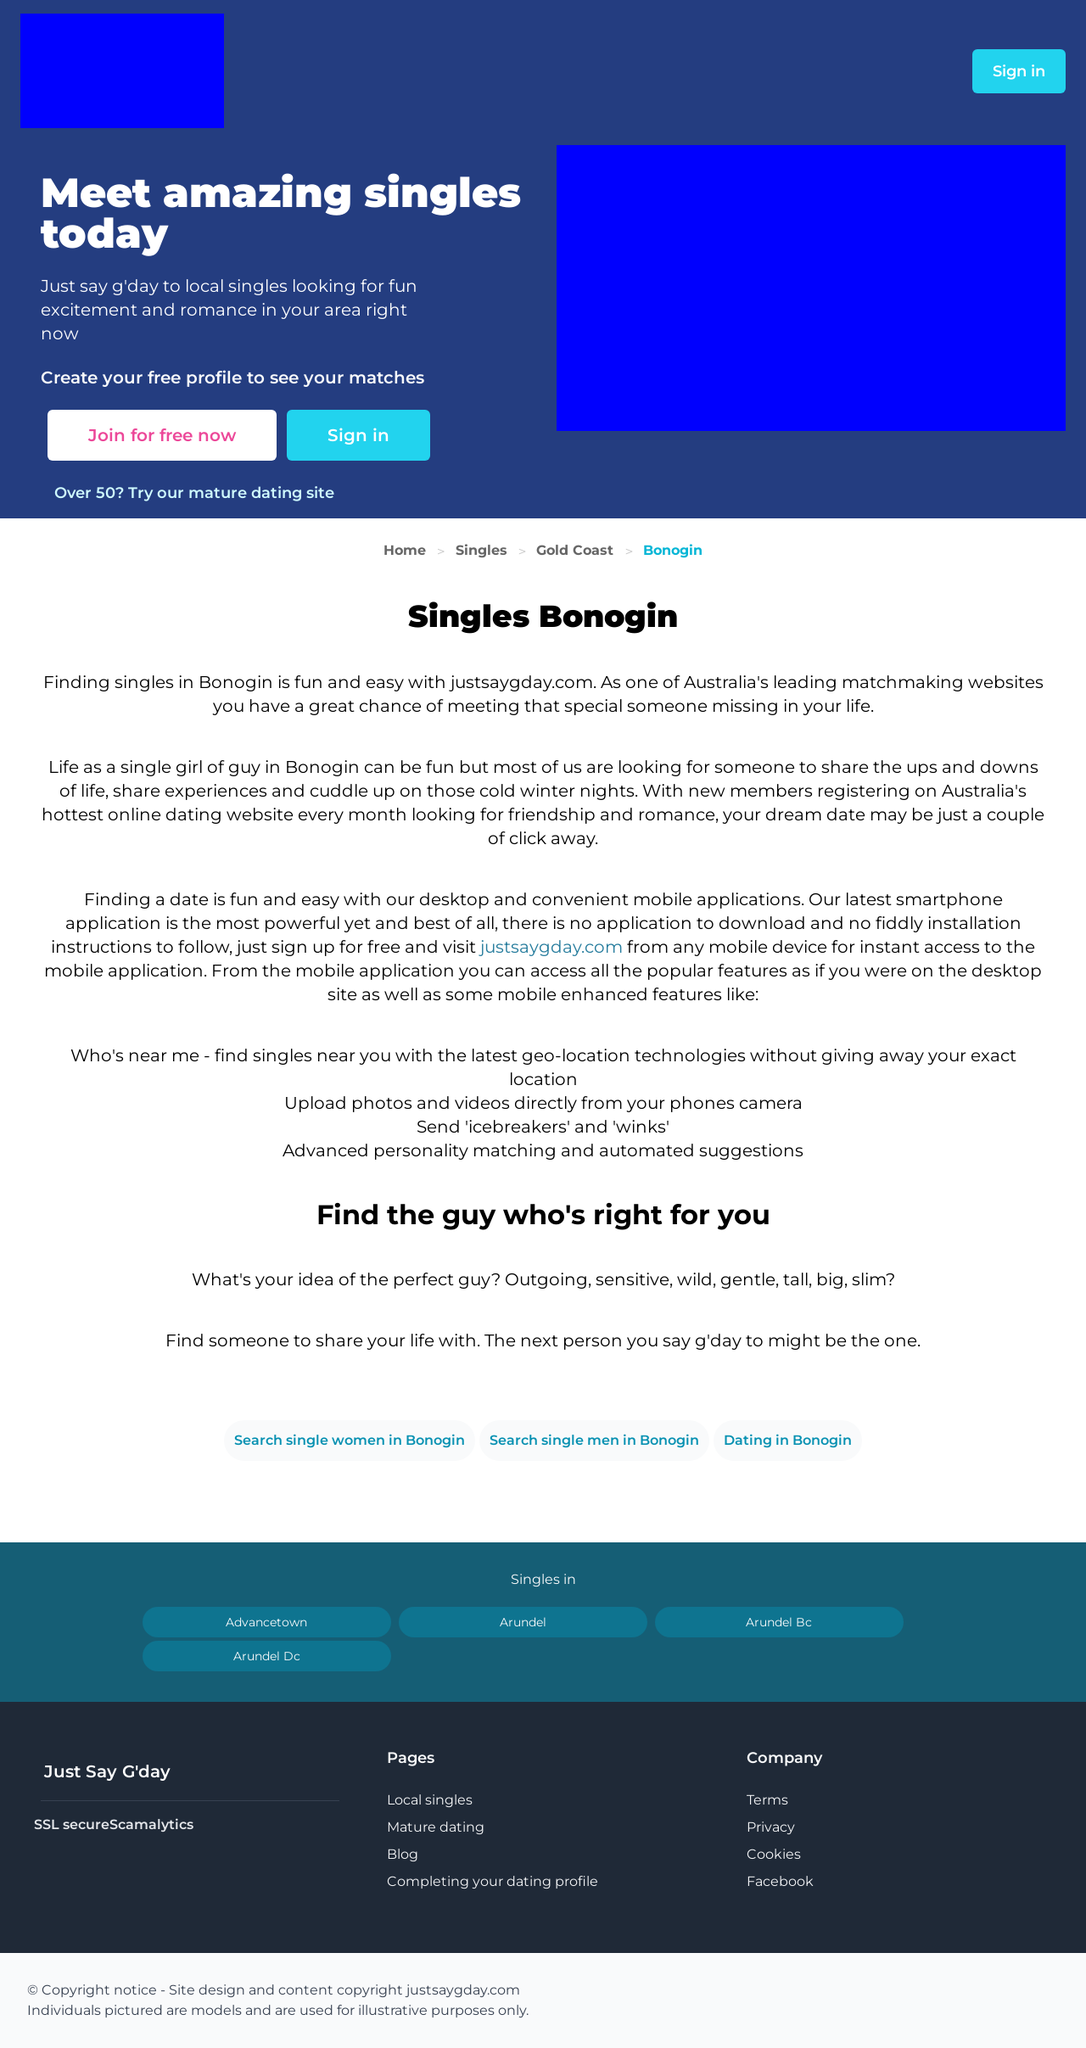Can you suggest some features that this dating website could include to attract more users? To attract more users, the website could incorporate advanced search filters, such as interests or lifestyle choices, to make matches more relevant. Additionally, organizing local events, offering customized dating tips, introducing gamification elements like 'swipe' features or achievements, and ensuring robust security measures will enhance user engagement and trust.  How important are security features on a dating platform, and what are some essential ones to include? Security is crucial for dating platforms to protect user data and foster a safe environment. Essential security features include SSL encryption, verification processes for new profiles, options for users to report suspicious activity easily, and privacy settings that allow users to control what information is visible publicly and what is kept private. 